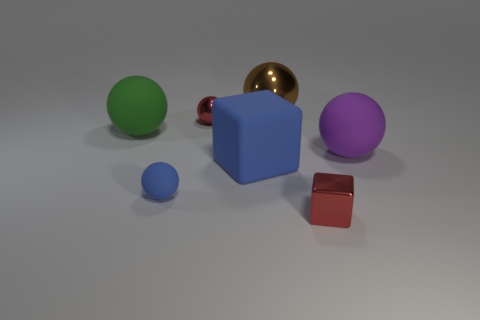Can you describe the color composition in this image? The image exhibits a diverse palette, featuring multiple objects with distinct colors. We see a big purple sphere, a smaller green sphere, a tiny blue sphere, and a large blue cube. Additionally, there's a small shiny golden sphere and a minuscule glossy red cube. 